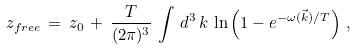<formula> <loc_0><loc_0><loc_500><loc_500>z _ { f r e e } \, = \, z _ { 0 } \, + \, \frac { T } { ( 2 \pi ) ^ { 3 } } \, \int \, d ^ { 3 } \, k \, \ln \left ( 1 - e ^ { - \omega ( { \vec { k } } ) / T } \right ) \, ,</formula> 